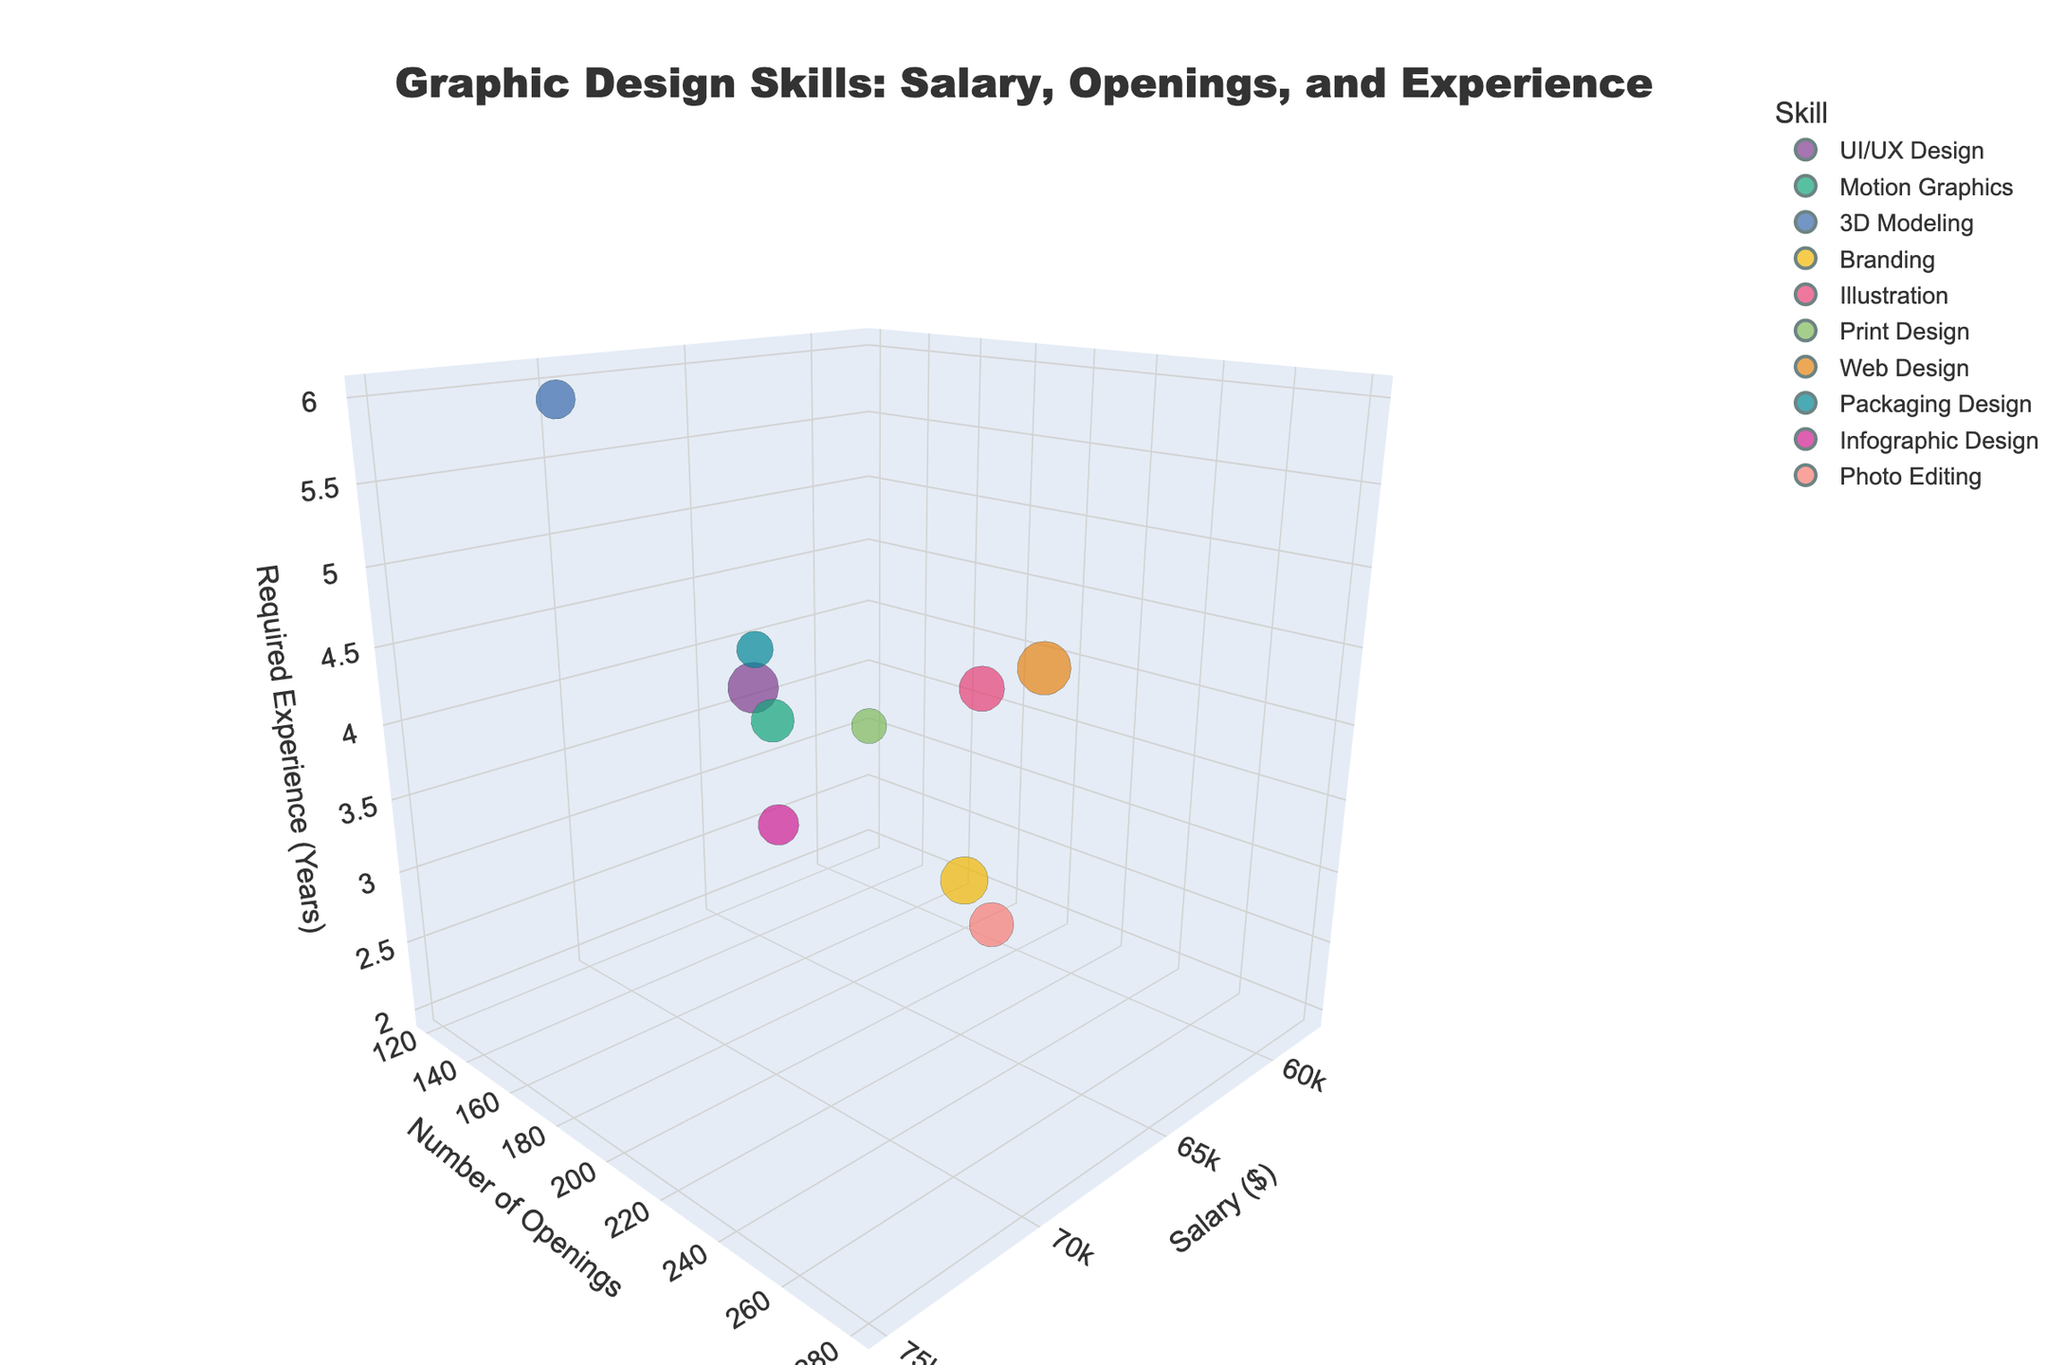What's the title of the figure? The title is usually displayed at the top center of the figure. In this case, the title of the figure is "Graphic Design Skills: Salary, Openings, and Experience".
Answer: Graphic Design Skills: Salary, Openings, and Experience Which skill has the highest number of job openings? To determine this, observe the Y-axis which represents the number of openings. The largest bubble along this axis will indicate the skill with the most job openings. "Web Design" has the highest number of job openings at 280.
Answer: Web Design What is the skill with the highest salary? To find the skill with the highest salary, we need to look along the X-axis, which represents the salary. The bubble farthest to the right will indicate the highest salary. "UI/UX Design" has the highest salary at $75,000.
Answer: UI/UX Design Which skill requires the most experience? Check the Z-axis which represents required years of experience. The bubble placed highest along this axis will indicate the skill requiring the most experience. "3D Modeling" requires the most experience with 6 years.
Answer: 3D Modeling Compare the salaries of "Motion Graphics" and "3D Modeling". Which is higher? To compare the salaries, we look at the X-axis positions of the bubbles for "Motion Graphics" and "3D Modeling". "3D Modeling" is positioned at $72,000, which is higher than "Motion Graphics" at $68,000.
Answer: 3D Modeling Which skill has the smallest number of job openings? By examining the smallest bubble along the Y-axis (number of openings), we see that "Print Design" has the smallest number of openings with 120.
Answer: Print Design What is the average salary of "Branding" and "Illustration"? To calculate the average salary, sum the salaries of "Branding" and "Illustration" and then divide by 2. The salaries are $65,000 and $62,000 respectively. So, ($65,000 + $62,000) / 2 = $63,500.
Answer: $63,500 How many skills require 4 years of experience? Count the number of bubbles placed at 4 on the Z-axis which represents the years of experience. The skills are "Motion Graphics", "Illustration", "Packaging Design". So, there are 3 skills in total.
Answer: 3 Which skill has a higher salary: "Photo Editing" or "Infographic Design"? Compare their positions along the X-axis (salary). "Infographic Design" is at $66,000 while "Photo Editing" is at $60,000. Therefore, "Infographic Design" has the higher salary.
Answer: Infographic Design What is the bubble color representing "Web Design"? Each bubble is colored according to the distinct skill it represents. "Web Design" is represented by a bubble with a particular color in the legend for easy identification (e.g., blue, red, green etc.).
Answer: Refer to the figure for specific color 